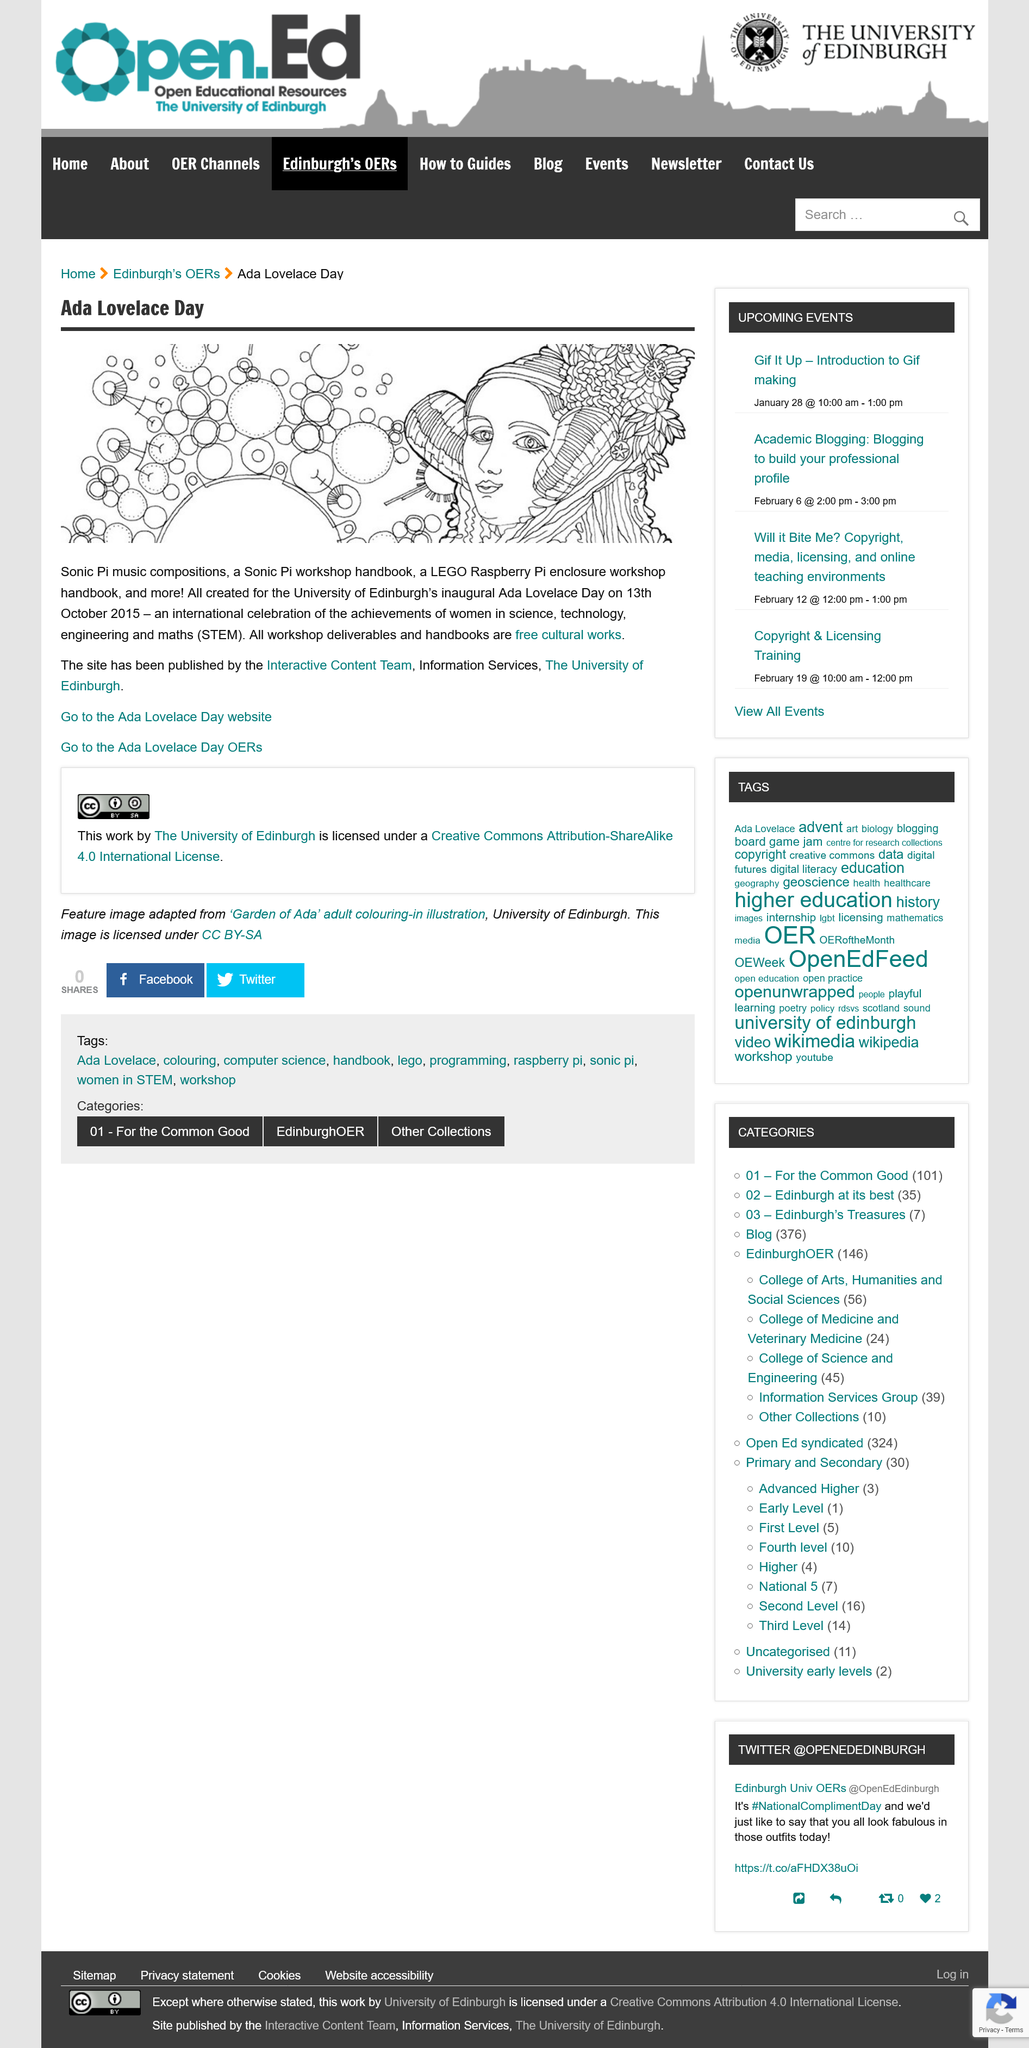Draw attention to some important aspects in this diagram. The illustration depicts Ada Lovelace. The University of Edinburgh held its first Ada Lovelace Day on October 13, 2015. Ada Lovelace Day celebrates the achievements of women in science, technology, engineering, and math. 